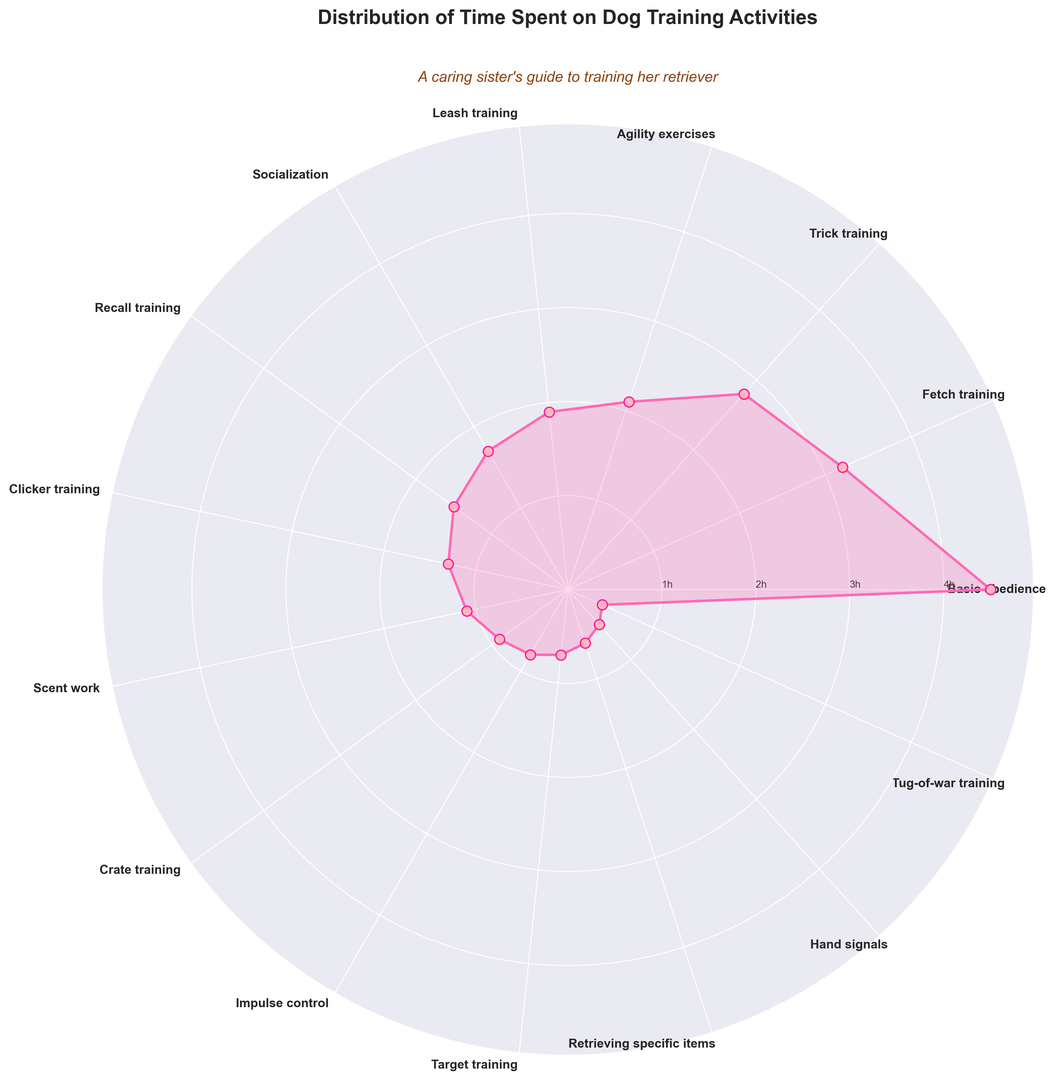which activities have a time spent of less than 1 hour? From the rose chart, identify the segments with values under 1 hour. The activities in these segments are impulse control, target training, retrieving specific items, hand signals, and tug-of-war training.
Answer: Impulse control, target training, retrieving specific items, hand signals, tug-of-war training what is the difference in time spent between basic obedience and leash training? Locate the segments for basic obedience and leash training on the rose chart. Basic obedience shows 4.5 hours, and leash training shows 1.9 hours. Calculate the difference: 4.5 - 1.9 = 2.6.
Answer: 2.6 hours how much more time is spent on fetch training compared to scent work? Identify the segments for fetch training and scent work. Fetch training shows 3.2 hours, and scent work shows 1.1 hours. Compute the difference: 3.2 - 1.1 = 2.1.
Answer: 2.1 hours which activity has the highest time spent? The rose chart's largest segment represents basic obedience training with 4.5 hours.
Answer: Basic obedience if you combine the time spent on trick training and agility exercises, what is the total? From the chart, trick training is 2.8 hours and agility exercises are 2.1 hours. The sum is 2.8 + 2.1 = 4.9.
Answer: 4.9 hours which two activities together equal the time spent on fetch training? Fetch training is 3.2 hours. Check various combinations. Socialization and recall training are 1.7 + 1.5 = 3.2 hours.
Answer: Socialization, recall training what is the average time spent across all activities? Sum all segments' times: 4.5 + 3.2 + 2.8 + 2.1 + 1.9 + 1.7 + 1.5 + 1.3 + 1.1 + 0.9 + 0.8 + 0.7 + 0.6 + 0.5 + 0.4 = 23. Leave out average, this is needed as the total time. Divide: 23/15 = 1.53.
Answer: 1.53 hours compare the time spent on socialization and clicker training. Which one is greater? Locate the segments for socialization (1.7 hours) and clicker training (1.3 hours). Socialization is greater.
Answer: Socialization how many activities have a time spent greater than 2 hours? Identify segments bigger than 2 hours: basic obedience, fetch training, trick training, and agility exercises (4 activities).
Answer: 4 activities which activity has the smallest time spent and how much is it? The smallest segment on the rose chart is for tug-of-war training at 0.4 hours.
Answer: Tug-of-war training, 0.4 hours 